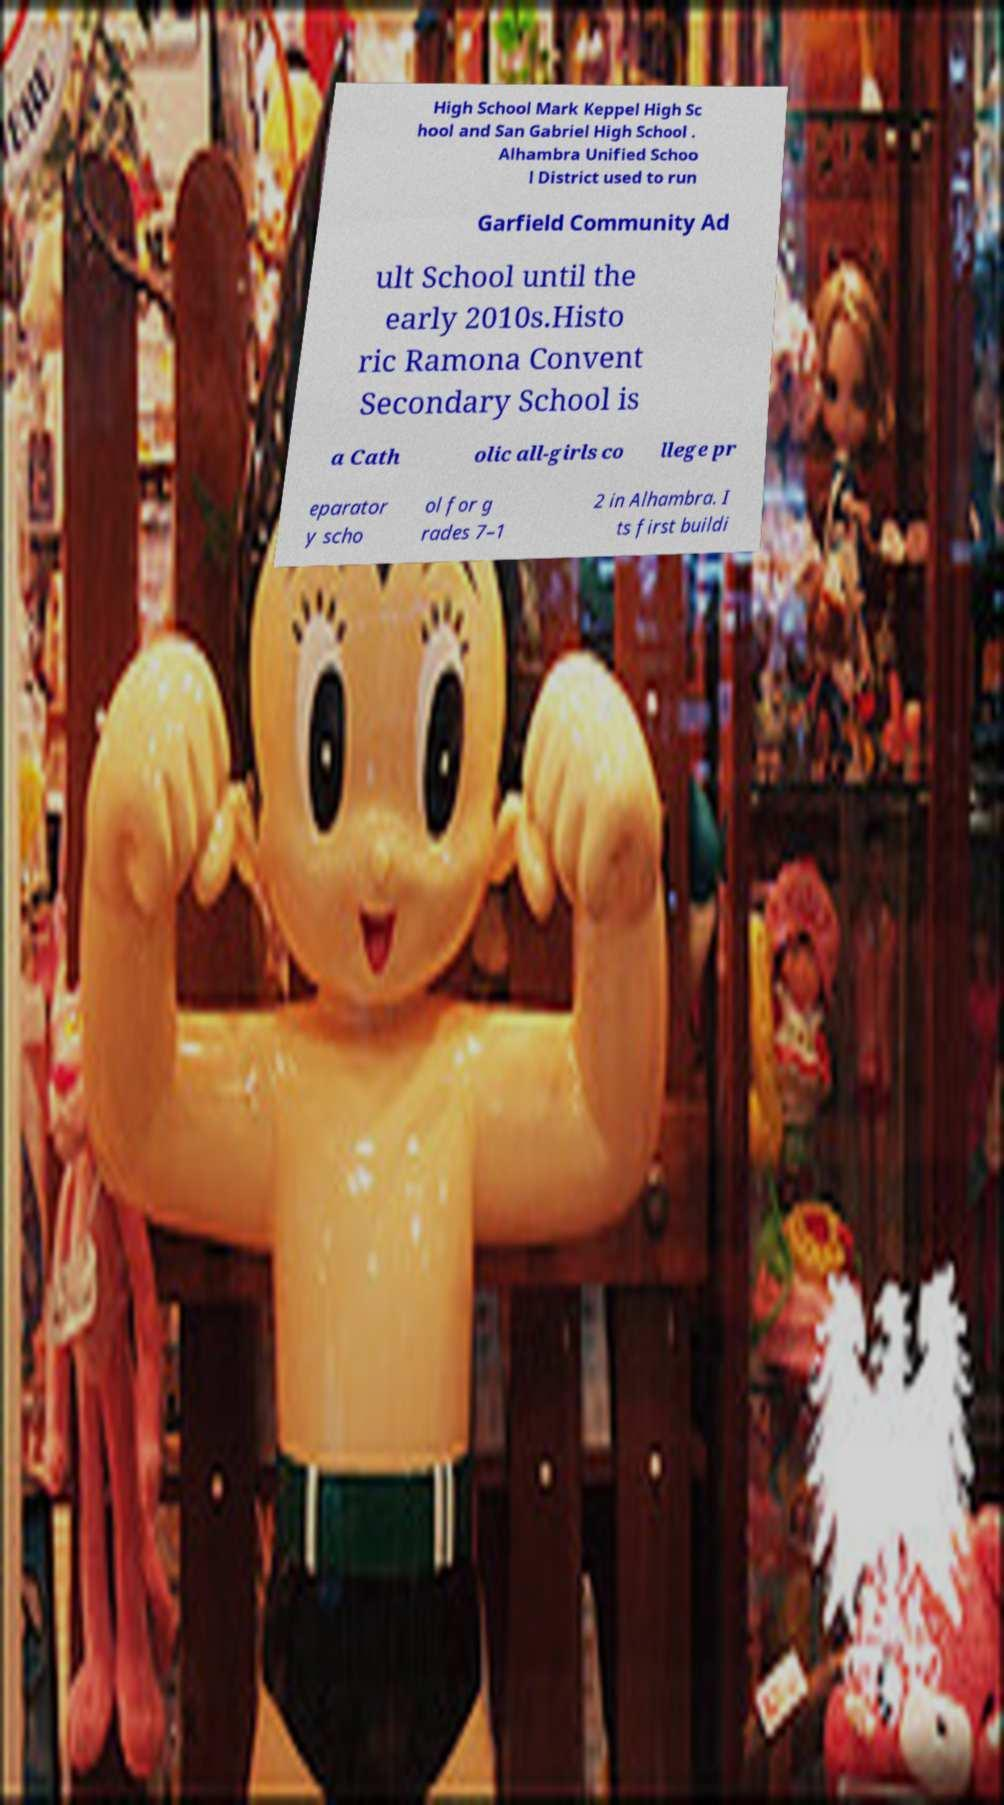Could you extract and type out the text from this image? High School Mark Keppel High Sc hool and San Gabriel High School . Alhambra Unified Schoo l District used to run Garfield Community Ad ult School until the early 2010s.Histo ric Ramona Convent Secondary School is a Cath olic all-girls co llege pr eparator y scho ol for g rades 7–1 2 in Alhambra. I ts first buildi 